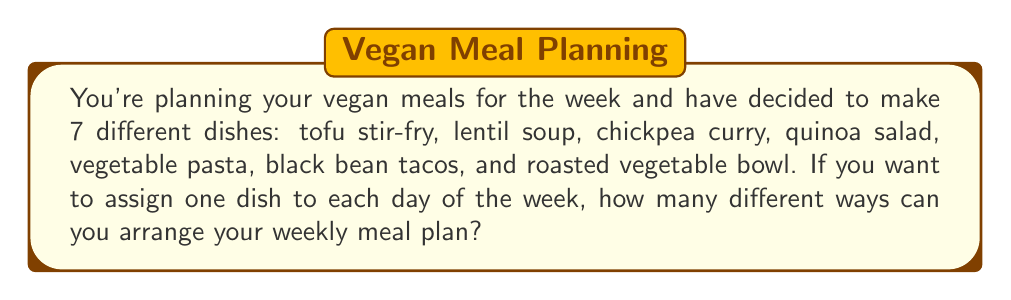What is the answer to this math problem? Let's approach this step-by-step:

1) We have 7 different vegan dishes and 7 days of the week. We need to arrange all 7 dishes, one for each day.

2) This is a perfect scenario for using permutations. We are arranging all items (dishes) with no repetition.

3) The formula for permutations of n distinct objects is:

   $$P(n) = n!$$

   Where n! (n factorial) is the product of all positive integers less than or equal to n.

4) In this case, n = 7 (we have 7 dishes to arrange).

5) Therefore, the number of ways to arrange the meals is:

   $$P(7) = 7!$$

6) Let's calculate 7!:
   
   $$7! = 7 \times 6 \times 5 \times 4 \times 3 \times 2 \times 1 = 5040$$

Thus, there are 5040 different ways to arrange your weekly vegan meal plan.
Answer: 5040 